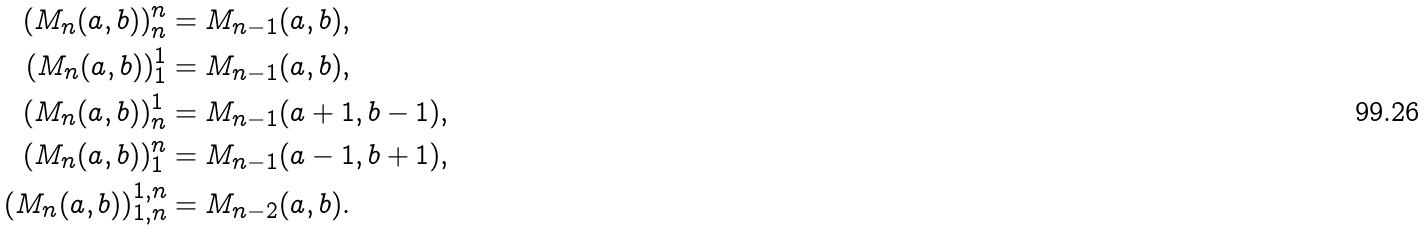Convert formula to latex. <formula><loc_0><loc_0><loc_500><loc_500>\left ( M _ { n } ( a , b ) \right ) _ { n } ^ { n } & = M _ { n - 1 } ( a , b ) , \\ \left ( M _ { n } ( a , b ) \right ) _ { 1 } ^ { 1 } & = M _ { n - 1 } ( a , b ) , \\ \left ( M _ { n } ( a , b ) \right ) _ { n } ^ { 1 } & = M _ { n - 1 } ( a + 1 , b - 1 ) , \\ \left ( M _ { n } ( a , b ) \right ) _ { 1 } ^ { n } & = M _ { n - 1 } ( a - 1 , b + 1 ) , \\ \left ( M _ { n } ( a , b ) \right ) _ { 1 , n } ^ { 1 , n } & = M _ { n - 2 } ( a , b ) .</formula> 